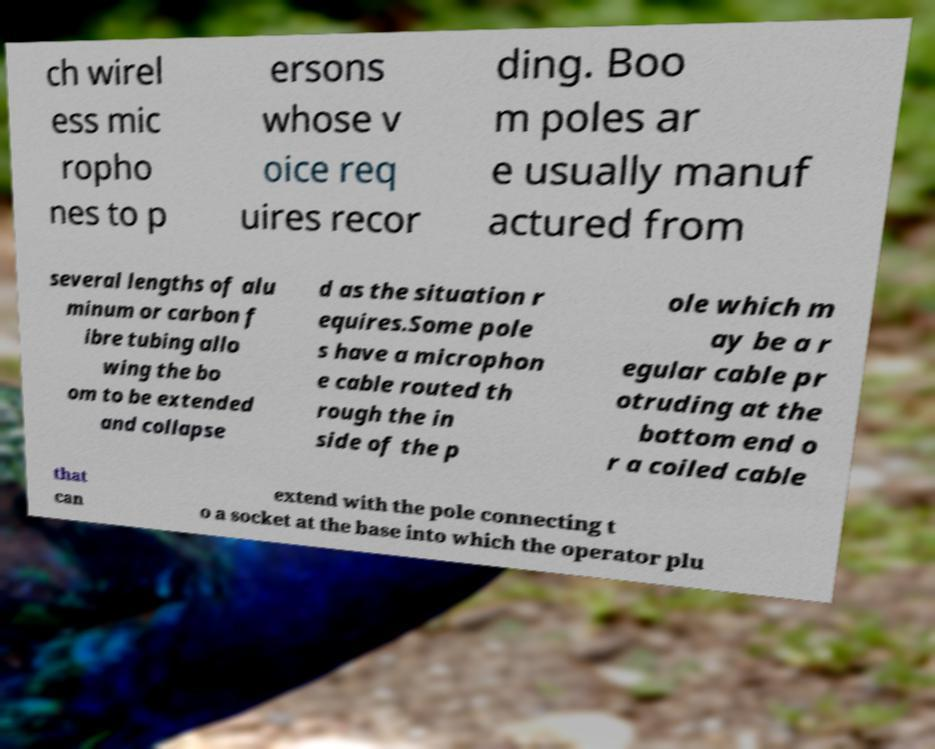There's text embedded in this image that I need extracted. Can you transcribe it verbatim? ch wirel ess mic ropho nes to p ersons whose v oice req uires recor ding. Boo m poles ar e usually manuf actured from several lengths of alu minum or carbon f ibre tubing allo wing the bo om to be extended and collapse d as the situation r equires.Some pole s have a microphon e cable routed th rough the in side of the p ole which m ay be a r egular cable pr otruding at the bottom end o r a coiled cable that can extend with the pole connecting t o a socket at the base into which the operator plu 